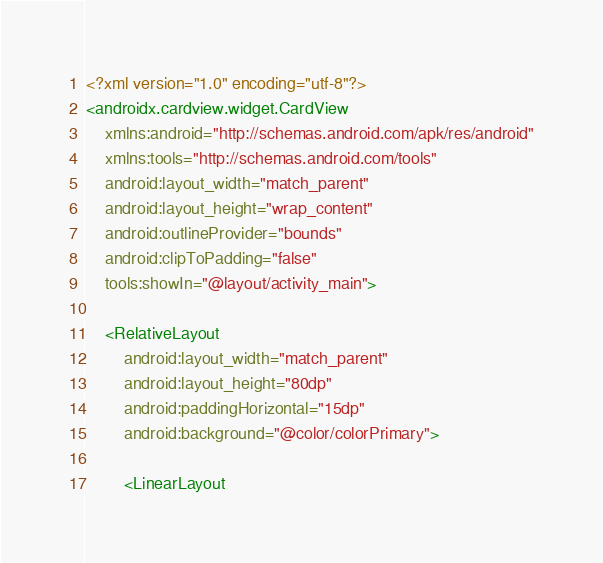<code> <loc_0><loc_0><loc_500><loc_500><_XML_><?xml version="1.0" encoding="utf-8"?>
<androidx.cardview.widget.CardView
    xmlns:android="http://schemas.android.com/apk/res/android"
    xmlns:tools="http://schemas.android.com/tools"
    android:layout_width="match_parent"
    android:layout_height="wrap_content"
    android:outlineProvider="bounds"
    android:clipToPadding="false"
    tools:showIn="@layout/activity_main">
    
    <RelativeLayout
        android:layout_width="match_parent"
        android:layout_height="80dp"
        android:paddingHorizontal="15dp"
        android:background="@color/colorPrimary">

        <LinearLayout</code> 